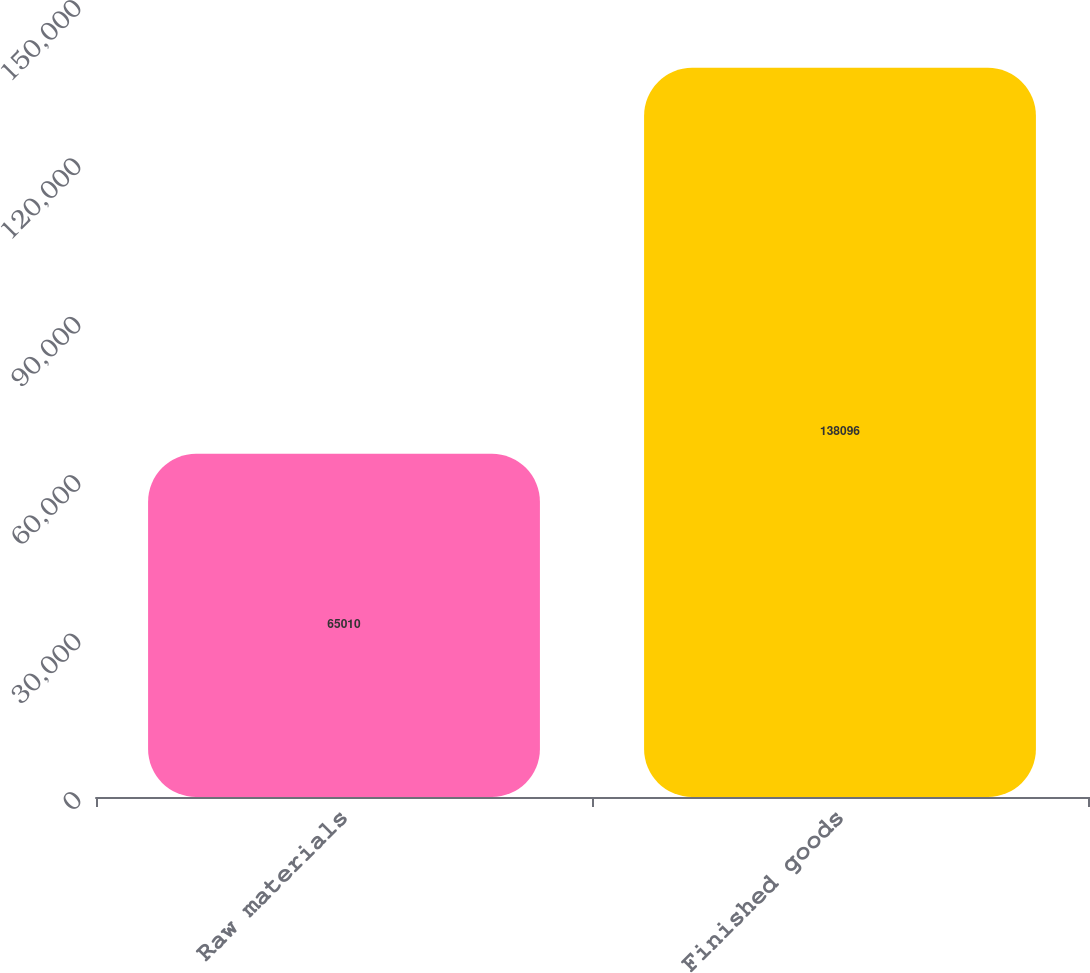<chart> <loc_0><loc_0><loc_500><loc_500><bar_chart><fcel>Raw materials<fcel>Finished goods<nl><fcel>65010<fcel>138096<nl></chart> 